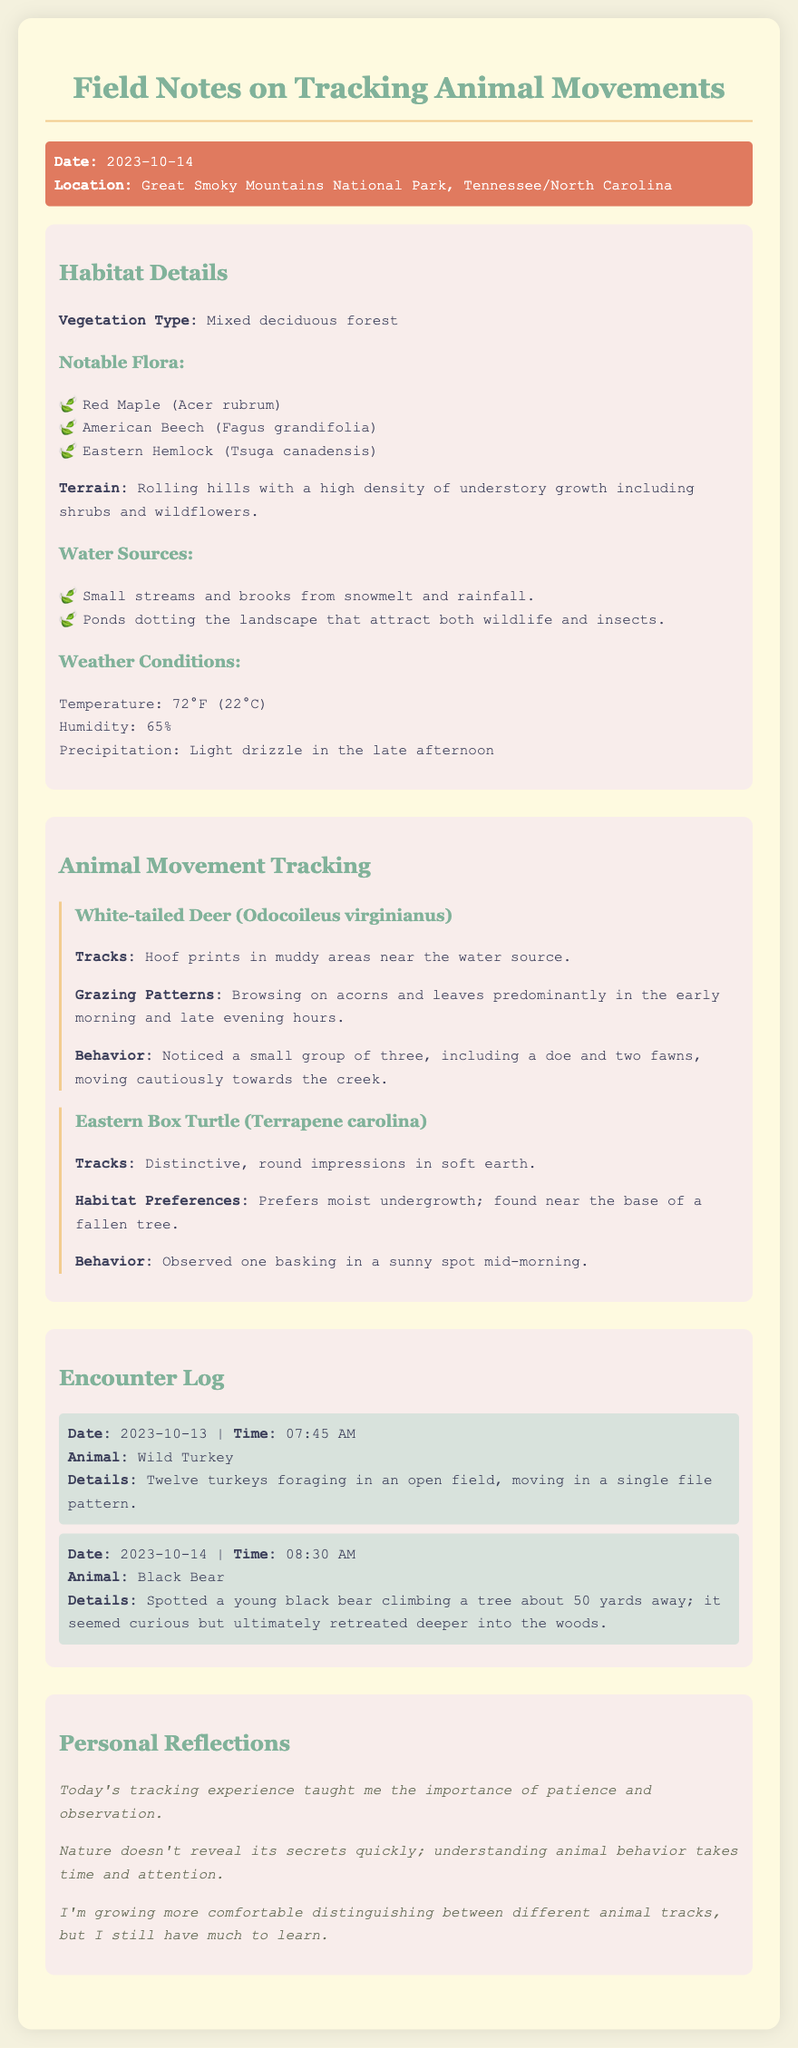What is the date of the field notes? The date is explicitly mentioned in the document header.
Answer: 2023-10-14 What is the location mentioned in the field notes? The location is provided in the info section of the document.
Answer: Great Smoky Mountains National Park, Tennessee/North Carolina What type of forest is described in the habitat details? The specific type of forest is indicated in the habitat details section.
Answer: Mixed deciduous forest What animal's tracks are found in muddy areas near water sources? The answer includes an animal mentioned under animal movement tracking.
Answer: White-tailed Deer How many turkeys were spotted in the encounter log? The number of turkeys is specified in the details of the encounter entry.
Answer: Twelve What behavior did the black bear exhibit when spotted? The behavior is described in the details of the encounter with the black bear.
Answer: Curious but ultimately retreated What notable flora includes Eastern Hemlock? The notable flora section lists specific plant species within the habitat details.
Answer: Eastern Hemlock (Tsuga canadensis) What lesson was learned from today's tracking experience? The reflections indicate the learned lesson throughout the document.
Answer: Patience and observation Where was the Eastern Box Turtle observed basking? The habitat preferences section gives information about the turtle's location.
Answer: In a sunny spot mid-morning 